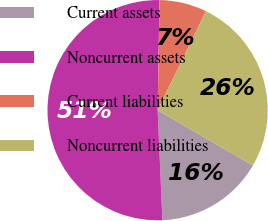<chart> <loc_0><loc_0><loc_500><loc_500><pie_chart><fcel>Current assets<fcel>Noncurrent assets<fcel>Current liabilities<fcel>Noncurrent liabilities<nl><fcel>15.94%<fcel>50.95%<fcel>6.96%<fcel>26.14%<nl></chart> 